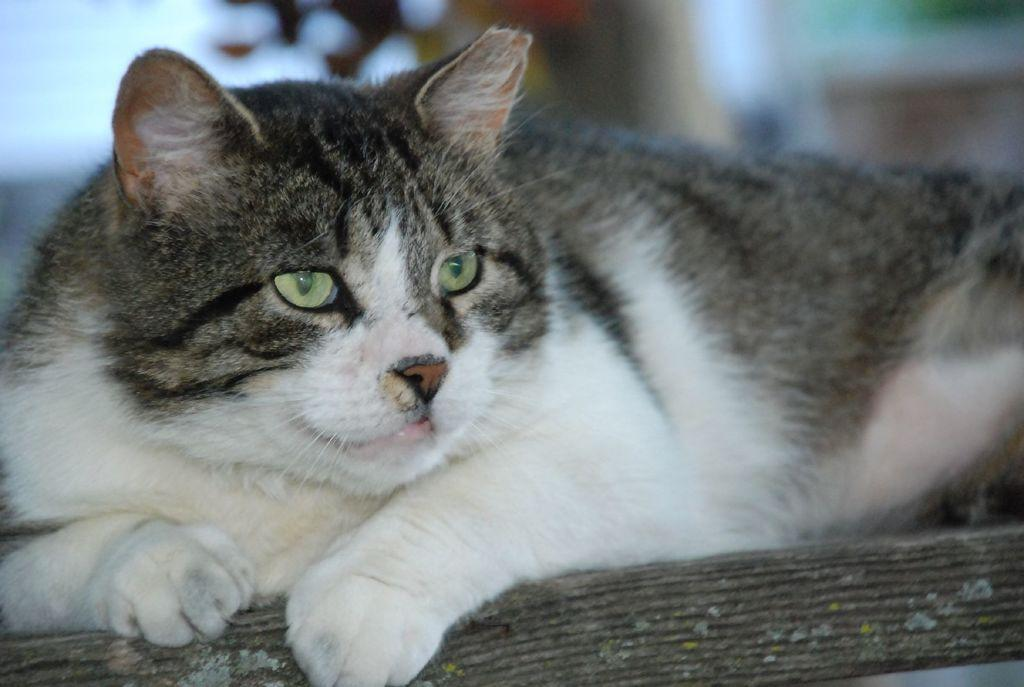What type of animal is in the picture? There is a cat in the picture. Can you describe the color of the cat? The cat is white with black coloring as well. What type of joke is the cat telling in the picture? There is no joke present in the image, as it features a cat with white and black coloring. 